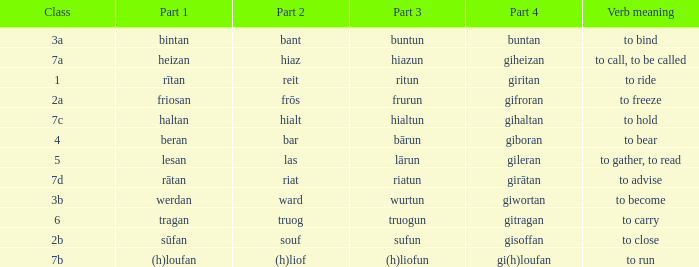What class in the word with part 4 "giheizan"? 7a. 